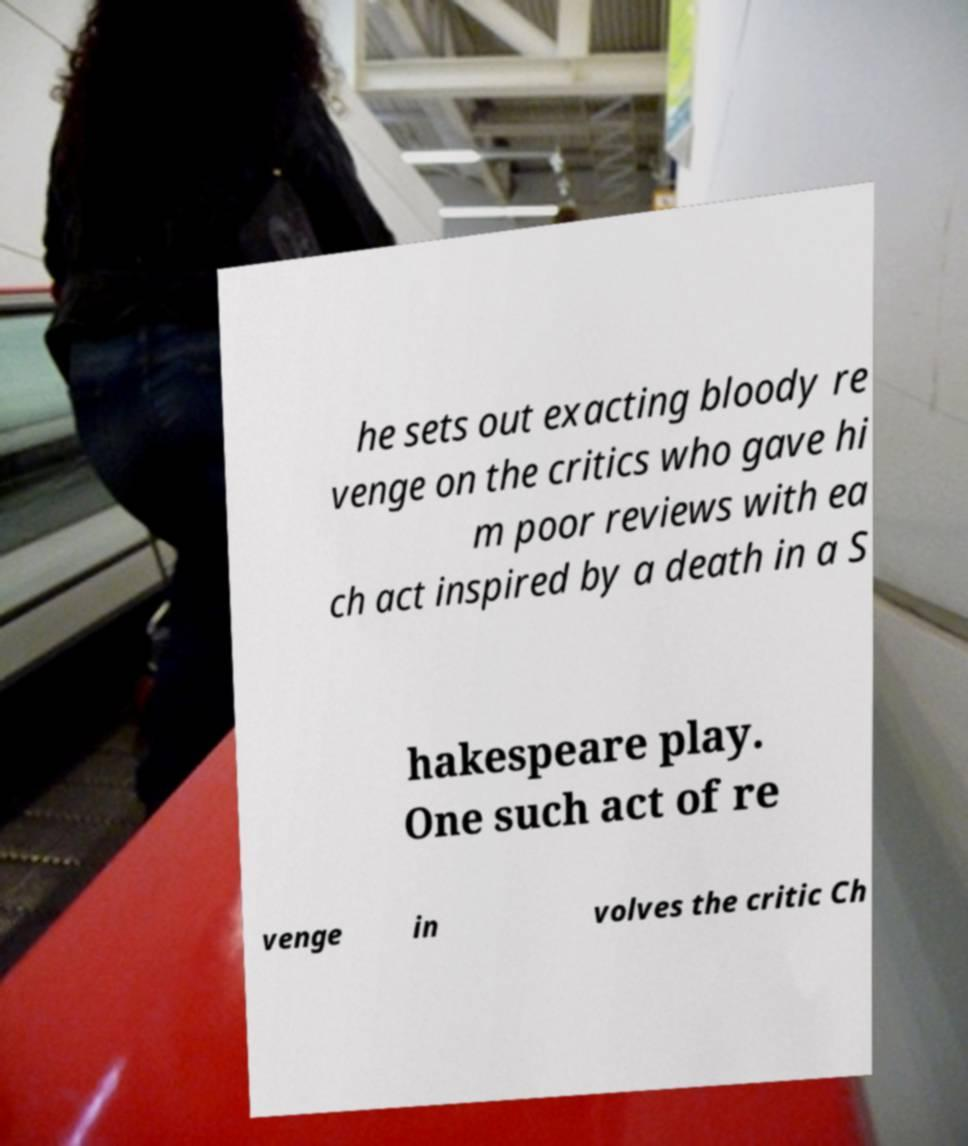Could you assist in decoding the text presented in this image and type it out clearly? he sets out exacting bloody re venge on the critics who gave hi m poor reviews with ea ch act inspired by a death in a S hakespeare play. One such act of re venge in volves the critic Ch 